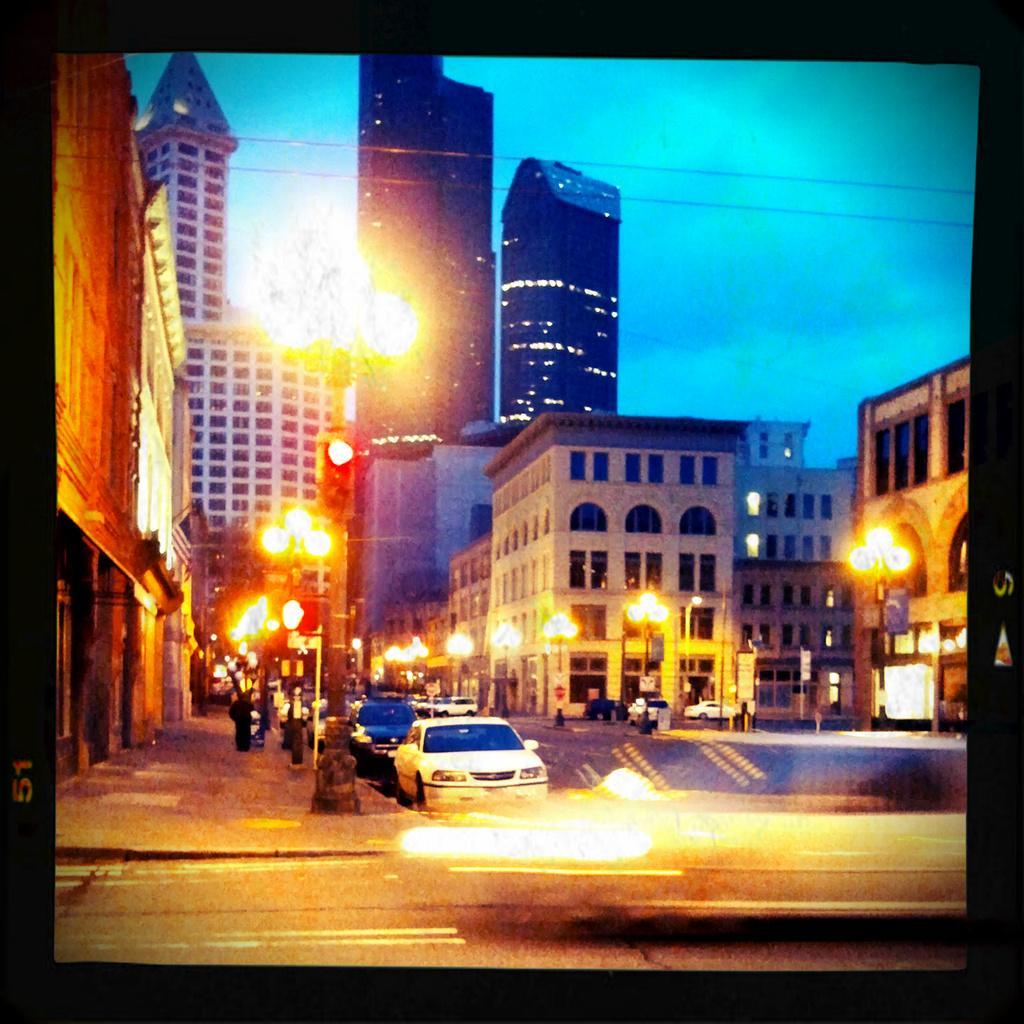Please provide a concise description of this image. There are vehicles and lamp poles in the foreground area of the image, there are buildings and the sky in the background. 